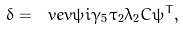<formula> <loc_0><loc_0><loc_500><loc_500>\delta = \ v e v { \bar { \psi } i \gamma _ { 5 } \tau _ { 2 } \lambda _ { 2 } C \bar { \psi } ^ { T } } ,</formula> 